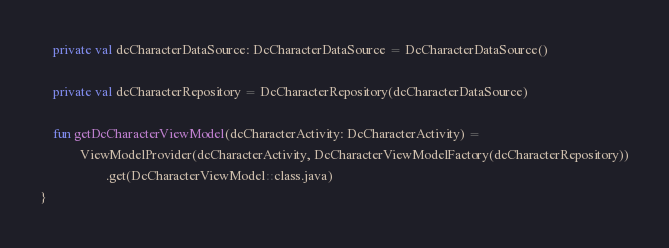<code> <loc_0><loc_0><loc_500><loc_500><_Kotlin_>
    private val dcCharacterDataSource: DcCharacterDataSource = DcCharacterDataSource()

    private val dcCharacterRepository = DcCharacterRepository(dcCharacterDataSource)

    fun getDcCharacterViewModel(dcCharacterActivity: DcCharacterActivity) =
            ViewModelProvider(dcCharacterActivity, DcCharacterViewModelFactory(dcCharacterRepository))
                    .get(DcCharacterViewModel::class.java)
}
</code> 